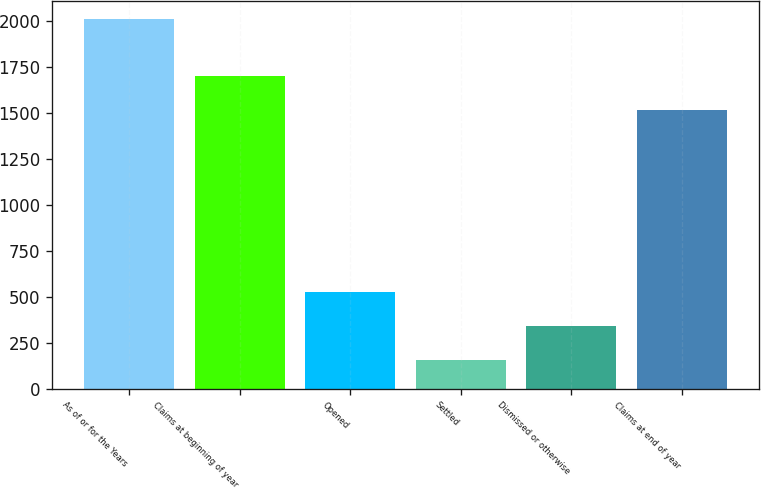<chart> <loc_0><loc_0><loc_500><loc_500><bar_chart><fcel>As of or for the Years<fcel>Claims at beginning of year<fcel>Opened<fcel>Settled<fcel>Dismissed or otherwise<fcel>Claims at end of year<nl><fcel>2013<fcel>1702.9<fcel>525.8<fcel>154<fcel>339.9<fcel>1517<nl></chart> 